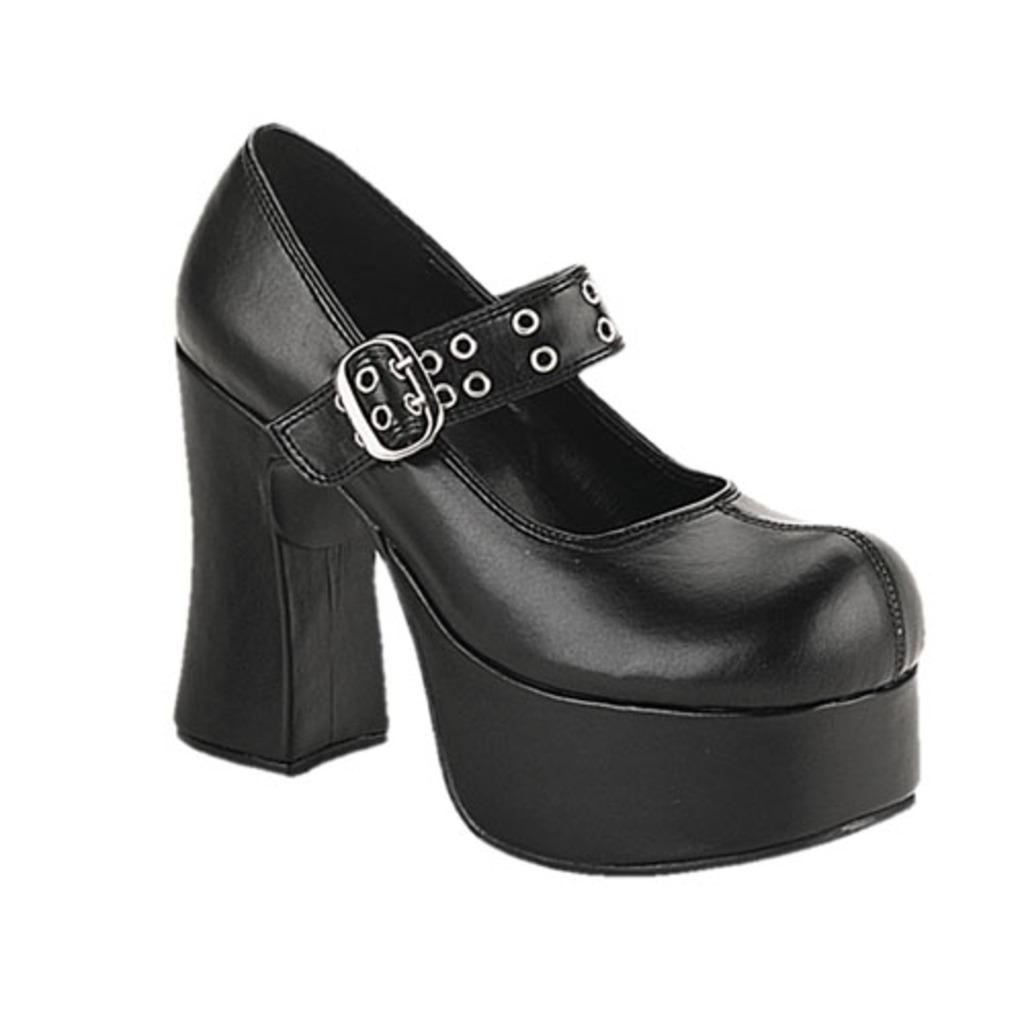Please provide a concise description of this image. In this image there is a footwear which is black in colour. 